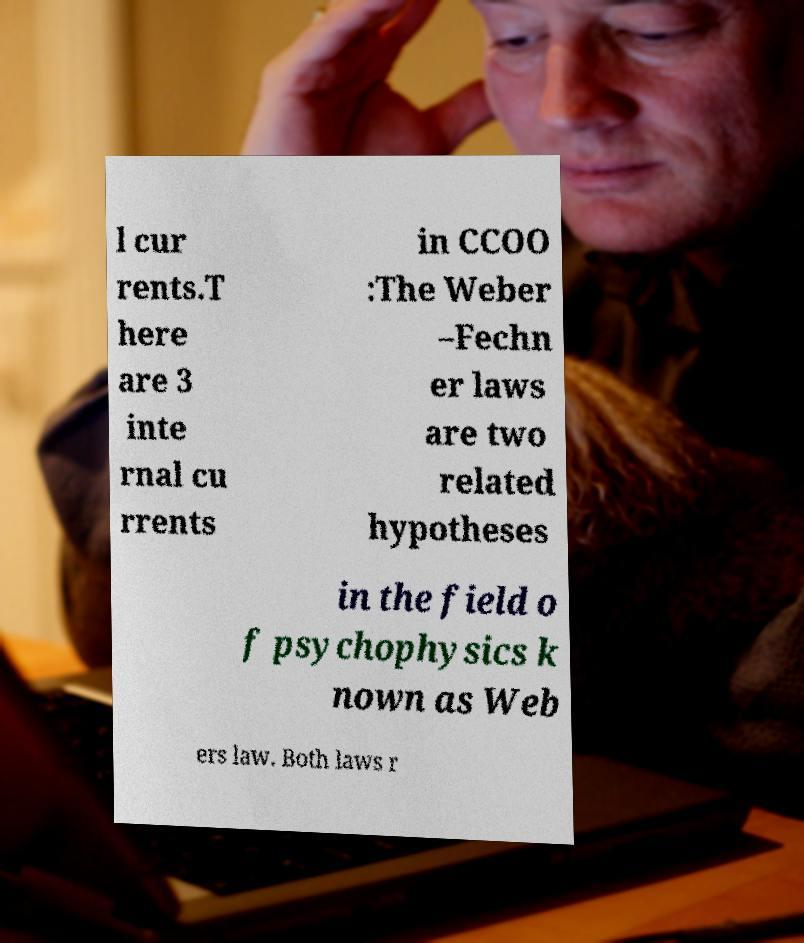I need the written content from this picture converted into text. Can you do that? l cur rents.T here are 3 inte rnal cu rrents in CCOO :The Weber –Fechn er laws are two related hypotheses in the field o f psychophysics k nown as Web ers law. Both laws r 